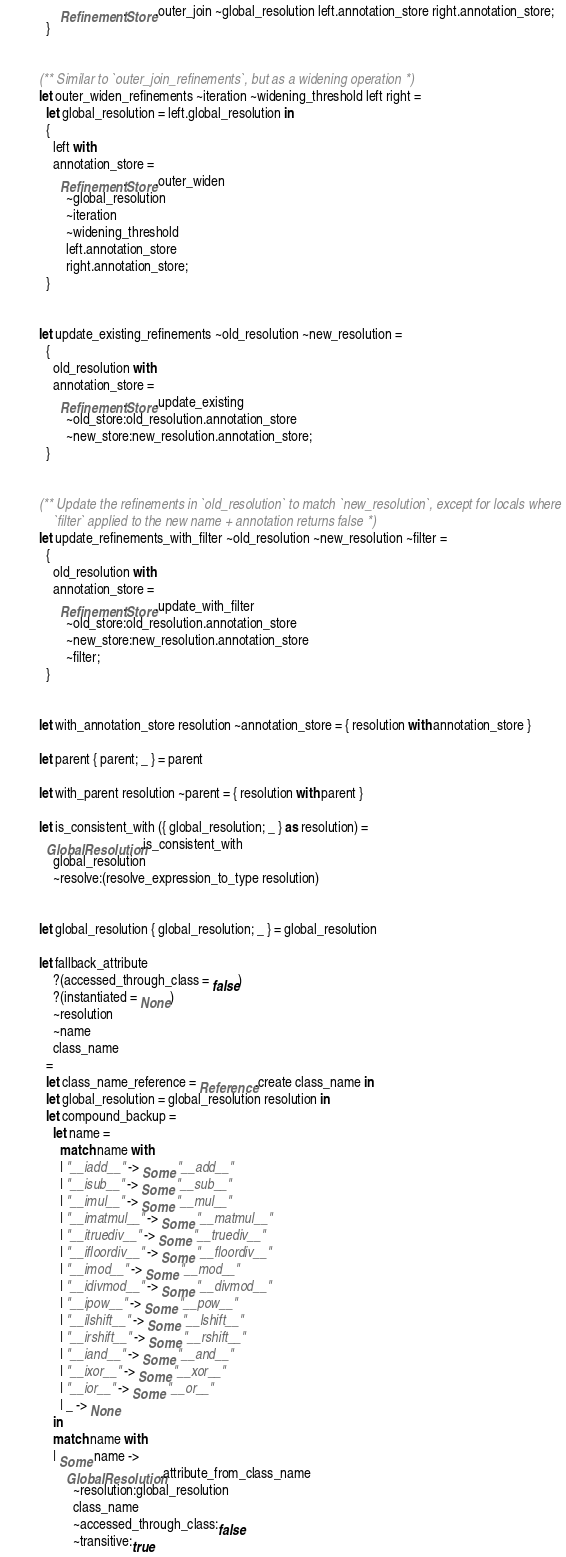<code> <loc_0><loc_0><loc_500><loc_500><_OCaml_>      Refinement.Store.outer_join ~global_resolution left.annotation_store right.annotation_store;
  }


(** Similar to `outer_join_refinements`, but as a widening operation *)
let outer_widen_refinements ~iteration ~widening_threshold left right =
  let global_resolution = left.global_resolution in
  {
    left with
    annotation_store =
      Refinement.Store.outer_widen
        ~global_resolution
        ~iteration
        ~widening_threshold
        left.annotation_store
        right.annotation_store;
  }


let update_existing_refinements ~old_resolution ~new_resolution =
  {
    old_resolution with
    annotation_store =
      Refinement.Store.update_existing
        ~old_store:old_resolution.annotation_store
        ~new_store:new_resolution.annotation_store;
  }


(** Update the refinements in `old_resolution` to match `new_resolution`, except for locals where
    `filter` applied to the new name + annotation returns false *)
let update_refinements_with_filter ~old_resolution ~new_resolution ~filter =
  {
    old_resolution with
    annotation_store =
      Refinement.Store.update_with_filter
        ~old_store:old_resolution.annotation_store
        ~new_store:new_resolution.annotation_store
        ~filter;
  }


let with_annotation_store resolution ~annotation_store = { resolution with annotation_store }

let parent { parent; _ } = parent

let with_parent resolution ~parent = { resolution with parent }

let is_consistent_with ({ global_resolution; _ } as resolution) =
  GlobalResolution.is_consistent_with
    global_resolution
    ~resolve:(resolve_expression_to_type resolution)


let global_resolution { global_resolution; _ } = global_resolution

let fallback_attribute
    ?(accessed_through_class = false)
    ?(instantiated = None)
    ~resolution
    ~name
    class_name
  =
  let class_name_reference = Reference.create class_name in
  let global_resolution = global_resolution resolution in
  let compound_backup =
    let name =
      match name with
      | "__iadd__" -> Some "__add__"
      | "__isub__" -> Some "__sub__"
      | "__imul__" -> Some "__mul__"
      | "__imatmul__" -> Some "__matmul__"
      | "__itruediv__" -> Some "__truediv__"
      | "__ifloordiv__" -> Some "__floordiv__"
      | "__imod__" -> Some "__mod__"
      | "__idivmod__" -> Some "__divmod__"
      | "__ipow__" -> Some "__pow__"
      | "__ilshift__" -> Some "__lshift__"
      | "__irshift__" -> Some "__rshift__"
      | "__iand__" -> Some "__and__"
      | "__ixor__" -> Some "__xor__"
      | "__ior__" -> Some "__or__"
      | _ -> None
    in
    match name with
    | Some name ->
        GlobalResolution.attribute_from_class_name
          ~resolution:global_resolution
          class_name
          ~accessed_through_class:false
          ~transitive:true</code> 